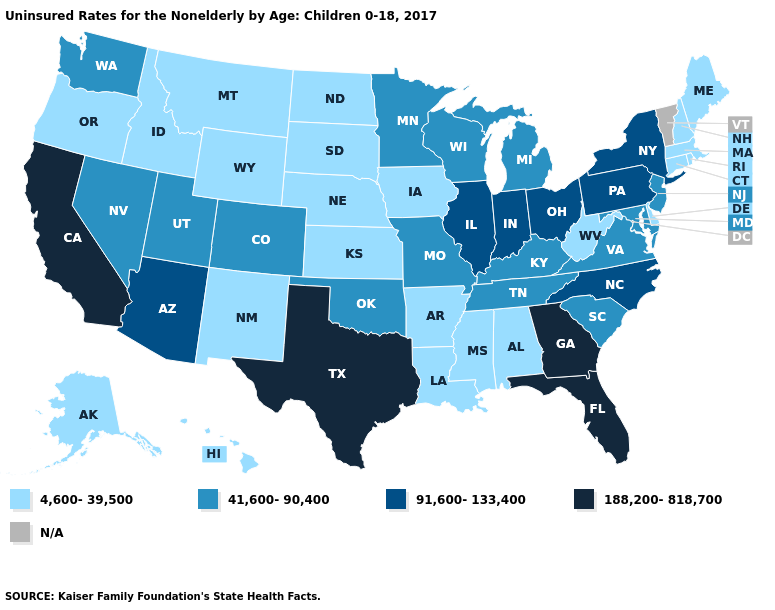What is the value of Mississippi?
Answer briefly. 4,600-39,500. Name the states that have a value in the range 41,600-90,400?
Answer briefly. Colorado, Kentucky, Maryland, Michigan, Minnesota, Missouri, Nevada, New Jersey, Oklahoma, South Carolina, Tennessee, Utah, Virginia, Washington, Wisconsin. Does Texas have the highest value in the USA?
Concise answer only. Yes. Does Indiana have the highest value in the USA?
Be succinct. No. What is the value of Connecticut?
Short answer required. 4,600-39,500. Name the states that have a value in the range 91,600-133,400?
Be succinct. Arizona, Illinois, Indiana, New York, North Carolina, Ohio, Pennsylvania. What is the value of Georgia?
Write a very short answer. 188,200-818,700. Among the states that border Texas , does Oklahoma have the highest value?
Write a very short answer. Yes. What is the lowest value in the USA?
Write a very short answer. 4,600-39,500. Does Indiana have the highest value in the MidWest?
Give a very brief answer. Yes. Does Oregon have the lowest value in the USA?
Answer briefly. Yes. Does California have the highest value in the USA?
Short answer required. Yes. What is the value of Illinois?
Quick response, please. 91,600-133,400. Which states have the lowest value in the MidWest?
Write a very short answer. Iowa, Kansas, Nebraska, North Dakota, South Dakota. Among the states that border Kansas , does Nebraska have the lowest value?
Keep it brief. Yes. 